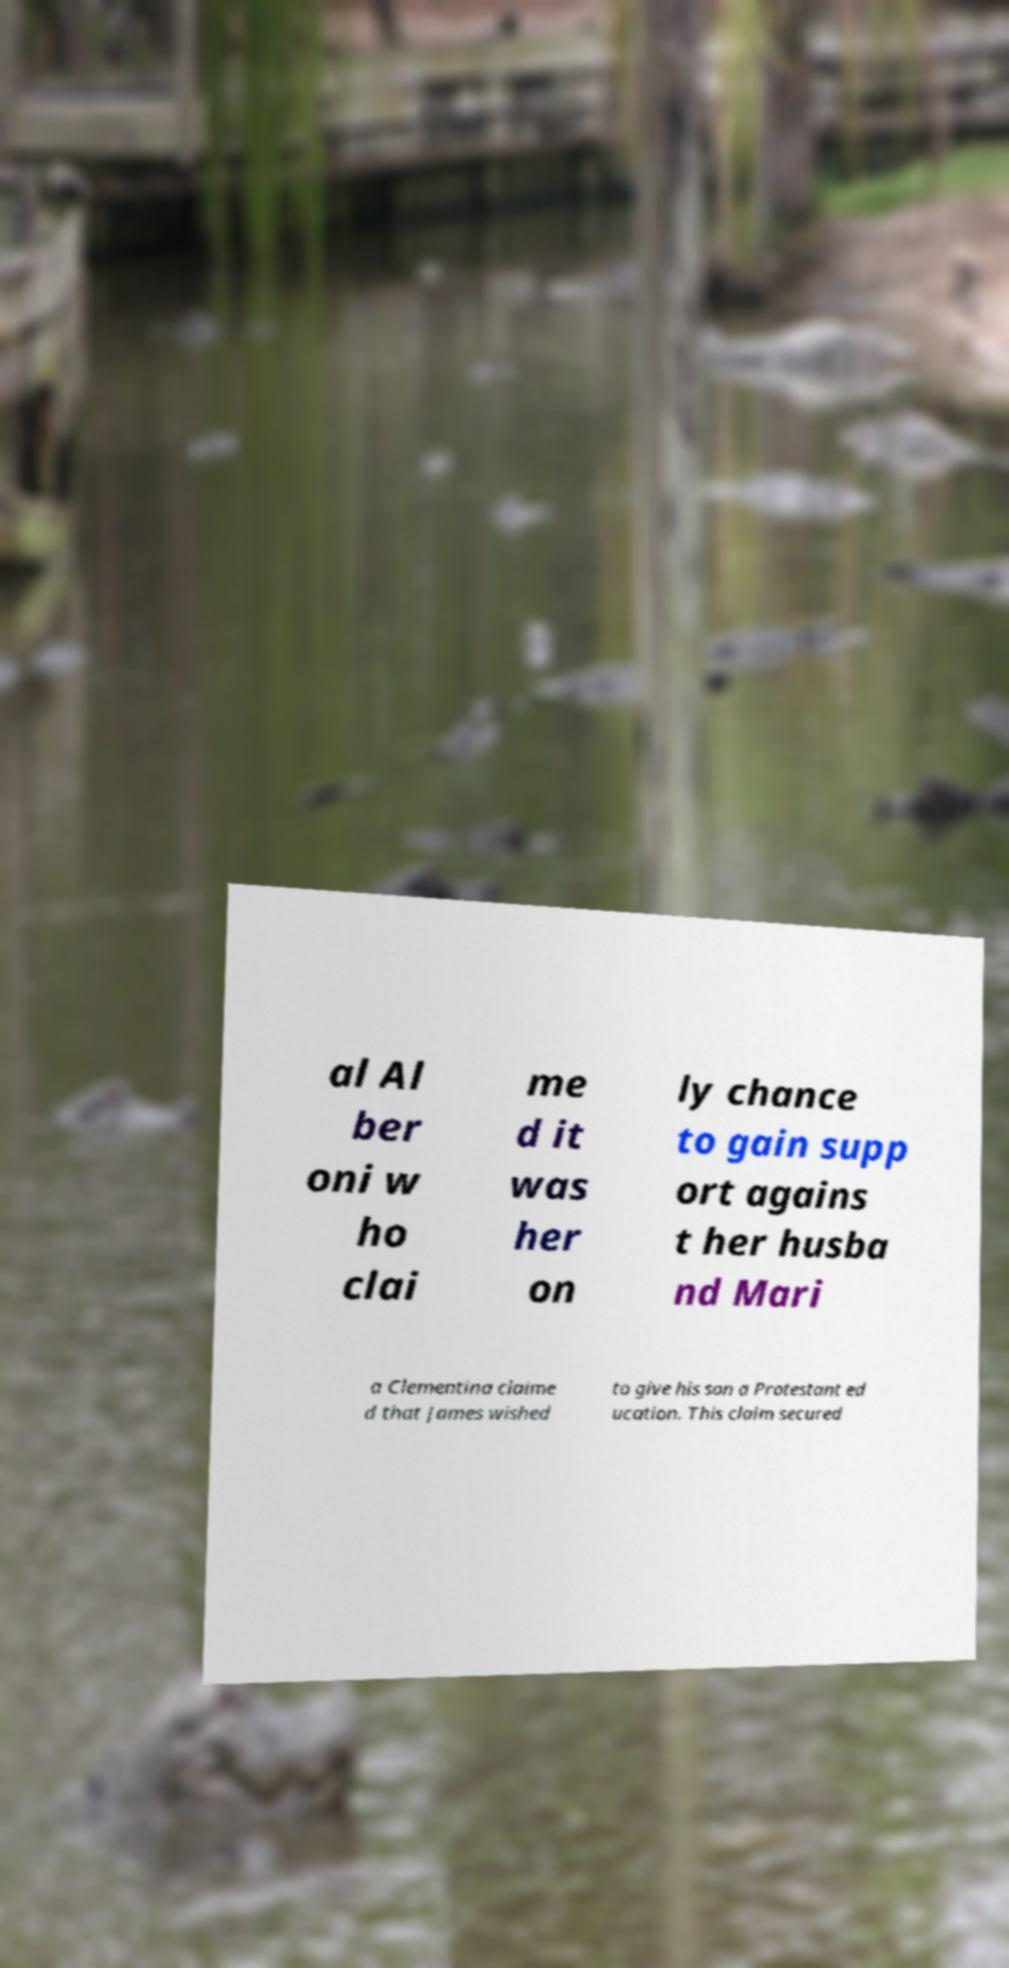For documentation purposes, I need the text within this image transcribed. Could you provide that? al Al ber oni w ho clai me d it was her on ly chance to gain supp ort agains t her husba nd Mari a Clementina claime d that James wished to give his son a Protestant ed ucation. This claim secured 